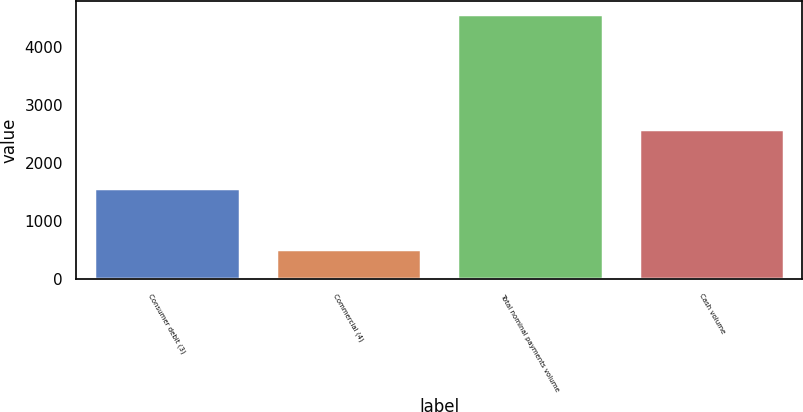Convert chart. <chart><loc_0><loc_0><loc_500><loc_500><bar_chart><fcel>Consumer debit (3)<fcel>Commercial (4)<fcel>Total nominal payments volume<fcel>Cash volume<nl><fcel>1580<fcel>514<fcel>4565<fcel>2591<nl></chart> 